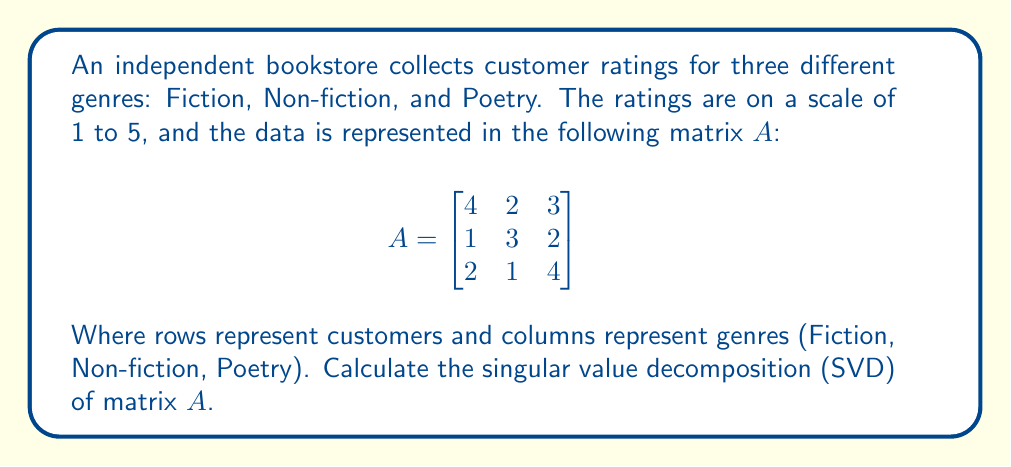Solve this math problem. To find the singular value decomposition of matrix $A$, we need to find matrices $U$, $\Sigma$, and $V^T$ such that $A = U\Sigma V^T$.

Step 1: Calculate $A^TA$ and $AA^T$

$$A^TA = \begin{bmatrix}
4 & 1 & 2 \\
2 & 3 & 1 \\
3 & 2 & 4
\end{bmatrix} \begin{bmatrix}
4 & 2 & 3 \\
1 & 3 & 2 \\
2 & 1 & 4
\end{bmatrix} = \begin{bmatrix}
21 & 13 & 22 \\
13 & 14 & 13 \\
22 & 13 & 29
\end{bmatrix}$$

$$AA^T = \begin{bmatrix}
4 & 2 & 3 \\
1 & 3 & 2 \\
2 & 1 & 4
\end{bmatrix} \begin{bmatrix}
4 & 1 & 2 \\
2 & 3 & 1 \\
3 & 2 & 4
\end{bmatrix} = \begin{bmatrix}
29 & 16 & 22 \\
16 & 14 & 13 \\
22 & 13 & 21
\end{bmatrix}$$

Step 2: Find eigenvalues of $A^TA$ (same as non-zero eigenvalues of $AA^T$)

The characteristic equation is:
$$(21-\lambda)(14-\lambda)(29-\lambda) - 13^2(29-\lambda) - 22^2(14-\lambda) + 2(13)(22)(13) = 0$$

Solving this equation gives us the eigenvalues: $\lambda_1 \approx 54.59$, $\lambda_2 \approx 8.41$, $\lambda_3 \approx 1.00$

Step 3: Calculate singular values

The singular values are the square roots of these eigenvalues:
$\sigma_1 \approx 7.39$, $\sigma_2 \approx 2.90$, $\sigma_3 \approx 1.00$

Step 4: Find right singular vectors (eigenvectors of $A^TA$)

For each eigenvalue, solve $(A^TA - \lambda I)v = 0$ to find the corresponding eigenvector. Normalize these vectors to get $v_1$, $v_2$, and $v_3$.

Step 5: Find left singular vectors

For each singular value $\sigma_i$, calculate $u_i = \frac{1}{\sigma_i}Av_i$

Step 6: Construct matrices $U$, $\Sigma$, and $V^T$

$U = [u_1 \mid u_2 \mid u_3]$
$\Sigma = \text{diag}(\sigma_1, \sigma_2, \sigma_3)$
$V^T = [v_1 \mid v_2 \mid v_3]^T$

The exact values of $U$ and $V^T$ depend on the precise calculations of eigenvectors, which can be done numerically.
Answer: $A = U\Sigma V^T$, where $\Sigma = \text{diag}(7.39, 2.90, 1.00)$ 